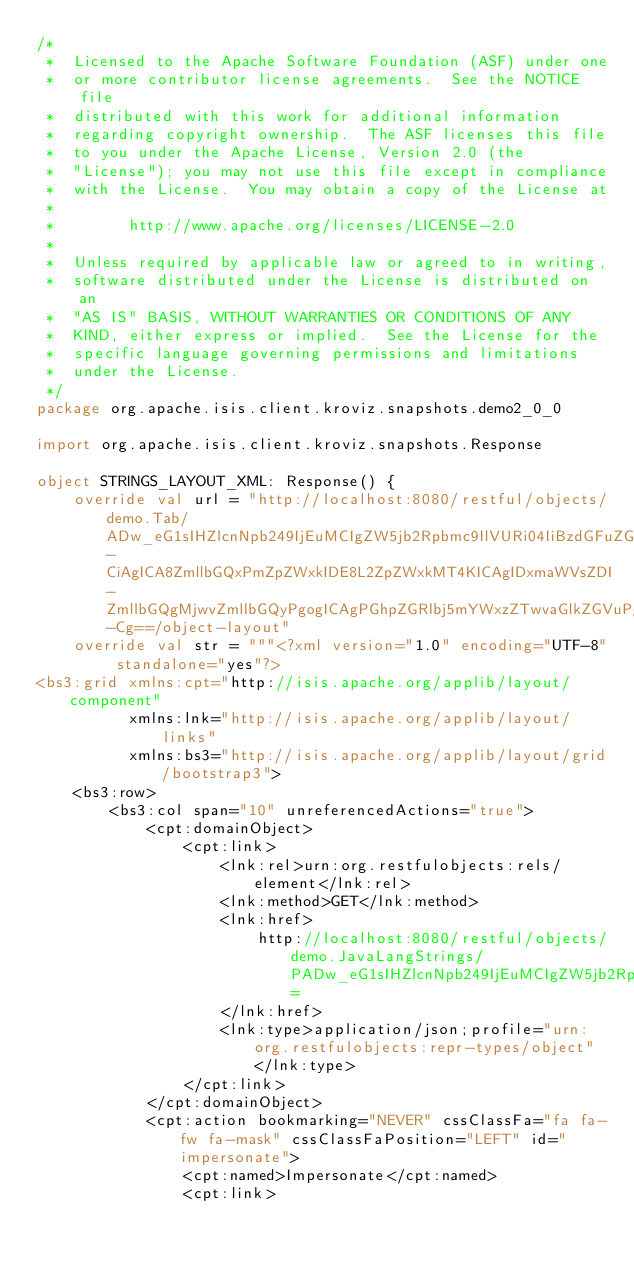<code> <loc_0><loc_0><loc_500><loc_500><_Kotlin_>/*
 *  Licensed to the Apache Software Foundation (ASF) under one
 *  or more contributor license agreements.  See the NOTICE file
 *  distributed with this work for additional information
 *  regarding copyright ownership.  The ASF licenses this file
 *  to you under the Apache License, Version 2.0 (the
 *  "License"); you may not use this file except in compliance
 *  with the License.  You may obtain a copy of the License at
 *
 *        http://www.apache.org/licenses/LICENSE-2.0
 *
 *  Unless required by applicable law or agreed to in writing,
 *  software distributed under the License is distributed on an
 *  "AS IS" BASIS, WITHOUT WARRANTIES OR CONDITIONS OF ANY
 *  KIND, either express or implied.  See the License for the
 *  specific language governing permissions and limitations
 *  under the License.
 */
package org.apache.isis.client.kroviz.snapshots.demo2_0_0

import org.apache.isis.client.kroviz.snapshots.Response

object STRINGS_LAYOUT_XML: Response() {
    override val url = "http://localhost:8080/restful/objects/demo.Tab/ADw_eG1sIHZlcnNpb249IjEuMCIgZW5jb2Rpbmc9IlVURi04IiBzdGFuZGFsb25lPSJ5ZXMiPz4KPERlbW8-CiAgICA8ZmllbGQxPmZpZWxkIDE8L2ZpZWxkMT4KICAgIDxmaWVsZDI-ZmllbGQgMjwvZmllbGQyPgogICAgPGhpZGRlbj5mYWxzZTwvaGlkZGVuPgo8L0RlbW8-Cg==/object-layout"
    override val str = """<?xml version="1.0" encoding="UTF-8" standalone="yes"?>
<bs3:grid xmlns:cpt="http://isis.apache.org/applib/layout/component"
          xmlns:lnk="http://isis.apache.org/applib/layout/links"
          xmlns:bs3="http://isis.apache.org/applib/layout/grid/bootstrap3">
    <bs3:row>
        <bs3:col span="10" unreferencedActions="true">
            <cpt:domainObject>
                <cpt:link>
                    <lnk:rel>urn:org.restfulobjects:rels/element</lnk:rel>
                    <lnk:method>GET</lnk:method>
                    <lnk:href>
                        http://localhost:8080/restful/objects/demo.JavaLangStrings/PADw_eG1sIHZlcnNpb249IjEuMCIgZW5jb2Rpbmc9IlVURi04IiBzdGFuZGFsb25lPSJ5ZXMiPz4KPERlbW8vPgo=
                    </lnk:href>
                    <lnk:type>application/json;profile="urn:org.restfulobjects:repr-types/object"</lnk:type>
                </cpt:link>
            </cpt:domainObject>
            <cpt:action bookmarking="NEVER" cssClassFa="fa fa-fw fa-mask" cssClassFaPosition="LEFT" id="impersonate">
                <cpt:named>Impersonate</cpt:named>
                <cpt:link></code> 